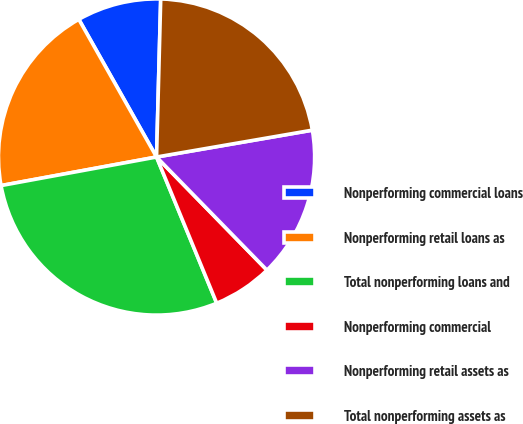Convert chart to OTSL. <chart><loc_0><loc_0><loc_500><loc_500><pie_chart><fcel>Nonperforming commercial loans<fcel>Nonperforming retail loans as<fcel>Total nonperforming loans and<fcel>Nonperforming commercial<fcel>Nonperforming retail assets as<fcel>Total nonperforming assets as<nl><fcel>8.6%<fcel>19.71%<fcel>28.32%<fcel>6.09%<fcel>15.41%<fcel>21.86%<nl></chart> 